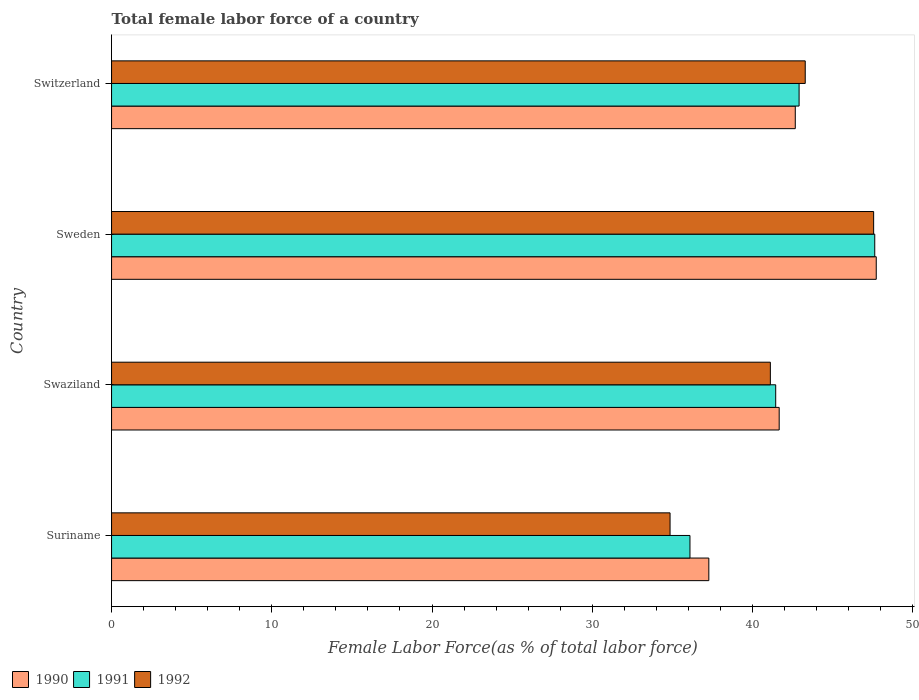Are the number of bars per tick equal to the number of legend labels?
Keep it short and to the point. Yes. Are the number of bars on each tick of the Y-axis equal?
Your answer should be very brief. Yes. How many bars are there on the 1st tick from the bottom?
Your answer should be compact. 3. What is the label of the 4th group of bars from the top?
Provide a short and direct response. Suriname. In how many cases, is the number of bars for a given country not equal to the number of legend labels?
Give a very brief answer. 0. What is the percentage of female labor force in 1991 in Suriname?
Provide a succinct answer. 36.1. Across all countries, what is the maximum percentage of female labor force in 1990?
Provide a succinct answer. 47.73. Across all countries, what is the minimum percentage of female labor force in 1990?
Your response must be concise. 37.28. In which country was the percentage of female labor force in 1991 minimum?
Make the answer very short. Suriname. What is the total percentage of female labor force in 1992 in the graph?
Offer a terse response. 166.84. What is the difference between the percentage of female labor force in 1991 in Suriname and that in Sweden?
Provide a succinct answer. -11.53. What is the difference between the percentage of female labor force in 1991 in Suriname and the percentage of female labor force in 1990 in Sweden?
Provide a short and direct response. -11.63. What is the average percentage of female labor force in 1990 per country?
Make the answer very short. 42.34. What is the difference between the percentage of female labor force in 1990 and percentage of female labor force in 1991 in Swaziland?
Give a very brief answer. 0.22. In how many countries, is the percentage of female labor force in 1992 greater than 34 %?
Offer a very short reply. 4. What is the ratio of the percentage of female labor force in 1990 in Suriname to that in Sweden?
Your answer should be compact. 0.78. What is the difference between the highest and the second highest percentage of female labor force in 1992?
Provide a short and direct response. 4.27. What is the difference between the highest and the lowest percentage of female labor force in 1992?
Make the answer very short. 12.71. In how many countries, is the percentage of female labor force in 1991 greater than the average percentage of female labor force in 1991 taken over all countries?
Give a very brief answer. 2. Is the sum of the percentage of female labor force in 1990 in Swaziland and Sweden greater than the maximum percentage of female labor force in 1991 across all countries?
Keep it short and to the point. Yes. Is it the case that in every country, the sum of the percentage of female labor force in 1990 and percentage of female labor force in 1991 is greater than the percentage of female labor force in 1992?
Ensure brevity in your answer.  Yes. How many bars are there?
Your response must be concise. 12. Are the values on the major ticks of X-axis written in scientific E-notation?
Provide a succinct answer. No. Does the graph contain any zero values?
Provide a short and direct response. No. How are the legend labels stacked?
Your response must be concise. Horizontal. What is the title of the graph?
Your response must be concise. Total female labor force of a country. What is the label or title of the X-axis?
Provide a succinct answer. Female Labor Force(as % of total labor force). What is the Female Labor Force(as % of total labor force) of 1990 in Suriname?
Give a very brief answer. 37.28. What is the Female Labor Force(as % of total labor force) of 1991 in Suriname?
Keep it short and to the point. 36.1. What is the Female Labor Force(as % of total labor force) of 1992 in Suriname?
Ensure brevity in your answer.  34.86. What is the Female Labor Force(as % of total labor force) in 1990 in Swaziland?
Provide a short and direct response. 41.67. What is the Female Labor Force(as % of total labor force) of 1991 in Swaziland?
Your answer should be compact. 41.45. What is the Female Labor Force(as % of total labor force) of 1992 in Swaziland?
Provide a succinct answer. 41.12. What is the Female Labor Force(as % of total labor force) in 1990 in Sweden?
Your answer should be very brief. 47.73. What is the Female Labor Force(as % of total labor force) in 1991 in Sweden?
Your answer should be compact. 47.63. What is the Female Labor Force(as % of total labor force) of 1992 in Sweden?
Your answer should be compact. 47.57. What is the Female Labor Force(as % of total labor force) of 1990 in Switzerland?
Provide a short and direct response. 42.67. What is the Female Labor Force(as % of total labor force) of 1991 in Switzerland?
Provide a short and direct response. 42.91. What is the Female Labor Force(as % of total labor force) in 1992 in Switzerland?
Keep it short and to the point. 43.3. Across all countries, what is the maximum Female Labor Force(as % of total labor force) of 1990?
Offer a very short reply. 47.73. Across all countries, what is the maximum Female Labor Force(as % of total labor force) of 1991?
Offer a very short reply. 47.63. Across all countries, what is the maximum Female Labor Force(as % of total labor force) in 1992?
Provide a short and direct response. 47.57. Across all countries, what is the minimum Female Labor Force(as % of total labor force) in 1990?
Keep it short and to the point. 37.28. Across all countries, what is the minimum Female Labor Force(as % of total labor force) of 1991?
Give a very brief answer. 36.1. Across all countries, what is the minimum Female Labor Force(as % of total labor force) of 1992?
Make the answer very short. 34.86. What is the total Female Labor Force(as % of total labor force) in 1990 in the graph?
Offer a terse response. 169.35. What is the total Female Labor Force(as % of total labor force) in 1991 in the graph?
Offer a terse response. 168.1. What is the total Female Labor Force(as % of total labor force) in 1992 in the graph?
Provide a succinct answer. 166.84. What is the difference between the Female Labor Force(as % of total labor force) in 1990 in Suriname and that in Swaziland?
Make the answer very short. -4.39. What is the difference between the Female Labor Force(as % of total labor force) of 1991 in Suriname and that in Swaziland?
Keep it short and to the point. -5.35. What is the difference between the Female Labor Force(as % of total labor force) of 1992 in Suriname and that in Swaziland?
Make the answer very short. -6.26. What is the difference between the Female Labor Force(as % of total labor force) in 1990 in Suriname and that in Sweden?
Offer a terse response. -10.45. What is the difference between the Female Labor Force(as % of total labor force) of 1991 in Suriname and that in Sweden?
Your response must be concise. -11.53. What is the difference between the Female Labor Force(as % of total labor force) of 1992 in Suriname and that in Sweden?
Your answer should be very brief. -12.71. What is the difference between the Female Labor Force(as % of total labor force) of 1990 in Suriname and that in Switzerland?
Make the answer very short. -5.4. What is the difference between the Female Labor Force(as % of total labor force) of 1991 in Suriname and that in Switzerland?
Offer a terse response. -6.81. What is the difference between the Female Labor Force(as % of total labor force) of 1992 in Suriname and that in Switzerland?
Your response must be concise. -8.44. What is the difference between the Female Labor Force(as % of total labor force) of 1990 in Swaziland and that in Sweden?
Ensure brevity in your answer.  -6.06. What is the difference between the Female Labor Force(as % of total labor force) of 1991 in Swaziland and that in Sweden?
Provide a succinct answer. -6.18. What is the difference between the Female Labor Force(as % of total labor force) of 1992 in Swaziland and that in Sweden?
Offer a very short reply. -6.45. What is the difference between the Female Labor Force(as % of total labor force) in 1990 in Swaziland and that in Switzerland?
Make the answer very short. -1. What is the difference between the Female Labor Force(as % of total labor force) in 1991 in Swaziland and that in Switzerland?
Offer a terse response. -1.46. What is the difference between the Female Labor Force(as % of total labor force) of 1992 in Swaziland and that in Switzerland?
Make the answer very short. -2.18. What is the difference between the Female Labor Force(as % of total labor force) in 1990 in Sweden and that in Switzerland?
Make the answer very short. 5.05. What is the difference between the Female Labor Force(as % of total labor force) of 1991 in Sweden and that in Switzerland?
Your response must be concise. 4.72. What is the difference between the Female Labor Force(as % of total labor force) in 1992 in Sweden and that in Switzerland?
Make the answer very short. 4.27. What is the difference between the Female Labor Force(as % of total labor force) of 1990 in Suriname and the Female Labor Force(as % of total labor force) of 1991 in Swaziland?
Provide a short and direct response. -4.17. What is the difference between the Female Labor Force(as % of total labor force) of 1990 in Suriname and the Female Labor Force(as % of total labor force) of 1992 in Swaziland?
Give a very brief answer. -3.84. What is the difference between the Female Labor Force(as % of total labor force) of 1991 in Suriname and the Female Labor Force(as % of total labor force) of 1992 in Swaziland?
Your answer should be compact. -5.02. What is the difference between the Female Labor Force(as % of total labor force) of 1990 in Suriname and the Female Labor Force(as % of total labor force) of 1991 in Sweden?
Your answer should be compact. -10.36. What is the difference between the Female Labor Force(as % of total labor force) of 1990 in Suriname and the Female Labor Force(as % of total labor force) of 1992 in Sweden?
Provide a short and direct response. -10.29. What is the difference between the Female Labor Force(as % of total labor force) in 1991 in Suriname and the Female Labor Force(as % of total labor force) in 1992 in Sweden?
Keep it short and to the point. -11.46. What is the difference between the Female Labor Force(as % of total labor force) of 1990 in Suriname and the Female Labor Force(as % of total labor force) of 1991 in Switzerland?
Offer a very short reply. -5.63. What is the difference between the Female Labor Force(as % of total labor force) of 1990 in Suriname and the Female Labor Force(as % of total labor force) of 1992 in Switzerland?
Your answer should be compact. -6.02. What is the difference between the Female Labor Force(as % of total labor force) of 1991 in Suriname and the Female Labor Force(as % of total labor force) of 1992 in Switzerland?
Offer a very short reply. -7.19. What is the difference between the Female Labor Force(as % of total labor force) in 1990 in Swaziland and the Female Labor Force(as % of total labor force) in 1991 in Sweden?
Keep it short and to the point. -5.96. What is the difference between the Female Labor Force(as % of total labor force) of 1990 in Swaziland and the Female Labor Force(as % of total labor force) of 1992 in Sweden?
Ensure brevity in your answer.  -5.9. What is the difference between the Female Labor Force(as % of total labor force) of 1991 in Swaziland and the Female Labor Force(as % of total labor force) of 1992 in Sweden?
Provide a short and direct response. -6.11. What is the difference between the Female Labor Force(as % of total labor force) of 1990 in Swaziland and the Female Labor Force(as % of total labor force) of 1991 in Switzerland?
Make the answer very short. -1.24. What is the difference between the Female Labor Force(as % of total labor force) of 1990 in Swaziland and the Female Labor Force(as % of total labor force) of 1992 in Switzerland?
Your answer should be very brief. -1.63. What is the difference between the Female Labor Force(as % of total labor force) of 1991 in Swaziland and the Female Labor Force(as % of total labor force) of 1992 in Switzerland?
Ensure brevity in your answer.  -1.84. What is the difference between the Female Labor Force(as % of total labor force) of 1990 in Sweden and the Female Labor Force(as % of total labor force) of 1991 in Switzerland?
Ensure brevity in your answer.  4.82. What is the difference between the Female Labor Force(as % of total labor force) of 1990 in Sweden and the Female Labor Force(as % of total labor force) of 1992 in Switzerland?
Offer a very short reply. 4.43. What is the difference between the Female Labor Force(as % of total labor force) of 1991 in Sweden and the Female Labor Force(as % of total labor force) of 1992 in Switzerland?
Make the answer very short. 4.34. What is the average Female Labor Force(as % of total labor force) of 1990 per country?
Ensure brevity in your answer.  42.34. What is the average Female Labor Force(as % of total labor force) of 1991 per country?
Your answer should be very brief. 42.03. What is the average Female Labor Force(as % of total labor force) of 1992 per country?
Ensure brevity in your answer.  41.71. What is the difference between the Female Labor Force(as % of total labor force) in 1990 and Female Labor Force(as % of total labor force) in 1991 in Suriname?
Your response must be concise. 1.18. What is the difference between the Female Labor Force(as % of total labor force) in 1990 and Female Labor Force(as % of total labor force) in 1992 in Suriname?
Your response must be concise. 2.42. What is the difference between the Female Labor Force(as % of total labor force) of 1991 and Female Labor Force(as % of total labor force) of 1992 in Suriname?
Ensure brevity in your answer.  1.24. What is the difference between the Female Labor Force(as % of total labor force) in 1990 and Female Labor Force(as % of total labor force) in 1991 in Swaziland?
Provide a succinct answer. 0.22. What is the difference between the Female Labor Force(as % of total labor force) in 1990 and Female Labor Force(as % of total labor force) in 1992 in Swaziland?
Your answer should be very brief. 0.55. What is the difference between the Female Labor Force(as % of total labor force) in 1991 and Female Labor Force(as % of total labor force) in 1992 in Swaziland?
Ensure brevity in your answer.  0.33. What is the difference between the Female Labor Force(as % of total labor force) of 1990 and Female Labor Force(as % of total labor force) of 1991 in Sweden?
Offer a very short reply. 0.09. What is the difference between the Female Labor Force(as % of total labor force) in 1990 and Female Labor Force(as % of total labor force) in 1992 in Sweden?
Provide a short and direct response. 0.16. What is the difference between the Female Labor Force(as % of total labor force) in 1991 and Female Labor Force(as % of total labor force) in 1992 in Sweden?
Make the answer very short. 0.07. What is the difference between the Female Labor Force(as % of total labor force) in 1990 and Female Labor Force(as % of total labor force) in 1991 in Switzerland?
Your answer should be compact. -0.24. What is the difference between the Female Labor Force(as % of total labor force) in 1990 and Female Labor Force(as % of total labor force) in 1992 in Switzerland?
Offer a terse response. -0.62. What is the difference between the Female Labor Force(as % of total labor force) of 1991 and Female Labor Force(as % of total labor force) of 1992 in Switzerland?
Offer a very short reply. -0.38. What is the ratio of the Female Labor Force(as % of total labor force) of 1990 in Suriname to that in Swaziland?
Provide a short and direct response. 0.89. What is the ratio of the Female Labor Force(as % of total labor force) in 1991 in Suriname to that in Swaziland?
Keep it short and to the point. 0.87. What is the ratio of the Female Labor Force(as % of total labor force) of 1992 in Suriname to that in Swaziland?
Make the answer very short. 0.85. What is the ratio of the Female Labor Force(as % of total labor force) in 1990 in Suriname to that in Sweden?
Provide a succinct answer. 0.78. What is the ratio of the Female Labor Force(as % of total labor force) in 1991 in Suriname to that in Sweden?
Your answer should be compact. 0.76. What is the ratio of the Female Labor Force(as % of total labor force) of 1992 in Suriname to that in Sweden?
Keep it short and to the point. 0.73. What is the ratio of the Female Labor Force(as % of total labor force) in 1990 in Suriname to that in Switzerland?
Make the answer very short. 0.87. What is the ratio of the Female Labor Force(as % of total labor force) in 1991 in Suriname to that in Switzerland?
Provide a short and direct response. 0.84. What is the ratio of the Female Labor Force(as % of total labor force) of 1992 in Suriname to that in Switzerland?
Make the answer very short. 0.81. What is the ratio of the Female Labor Force(as % of total labor force) in 1990 in Swaziland to that in Sweden?
Offer a terse response. 0.87. What is the ratio of the Female Labor Force(as % of total labor force) of 1991 in Swaziland to that in Sweden?
Provide a short and direct response. 0.87. What is the ratio of the Female Labor Force(as % of total labor force) in 1992 in Swaziland to that in Sweden?
Offer a very short reply. 0.86. What is the ratio of the Female Labor Force(as % of total labor force) of 1990 in Swaziland to that in Switzerland?
Give a very brief answer. 0.98. What is the ratio of the Female Labor Force(as % of total labor force) of 1992 in Swaziland to that in Switzerland?
Provide a succinct answer. 0.95. What is the ratio of the Female Labor Force(as % of total labor force) of 1990 in Sweden to that in Switzerland?
Ensure brevity in your answer.  1.12. What is the ratio of the Female Labor Force(as % of total labor force) in 1991 in Sweden to that in Switzerland?
Provide a succinct answer. 1.11. What is the ratio of the Female Labor Force(as % of total labor force) in 1992 in Sweden to that in Switzerland?
Provide a short and direct response. 1.1. What is the difference between the highest and the second highest Female Labor Force(as % of total labor force) of 1990?
Your answer should be compact. 5.05. What is the difference between the highest and the second highest Female Labor Force(as % of total labor force) in 1991?
Ensure brevity in your answer.  4.72. What is the difference between the highest and the second highest Female Labor Force(as % of total labor force) in 1992?
Provide a succinct answer. 4.27. What is the difference between the highest and the lowest Female Labor Force(as % of total labor force) of 1990?
Ensure brevity in your answer.  10.45. What is the difference between the highest and the lowest Female Labor Force(as % of total labor force) in 1991?
Keep it short and to the point. 11.53. What is the difference between the highest and the lowest Female Labor Force(as % of total labor force) in 1992?
Keep it short and to the point. 12.71. 